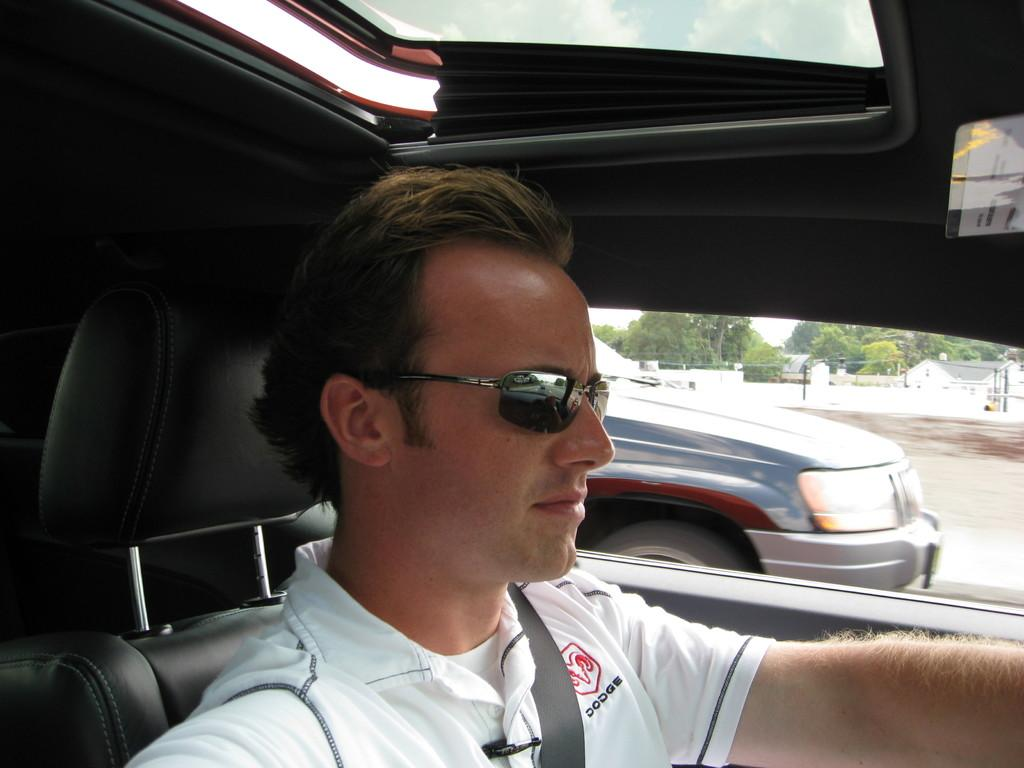What is the person in the image doing? There is a person riding in a car. What can be seen through the car window? There is a vehicle, buildings, trees, and the sky visible through the car window. What type of pleasure can be seen being enjoyed by the person in the image? There is no indication in the image of the person experiencing pleasure or engaging in any specific activity. 